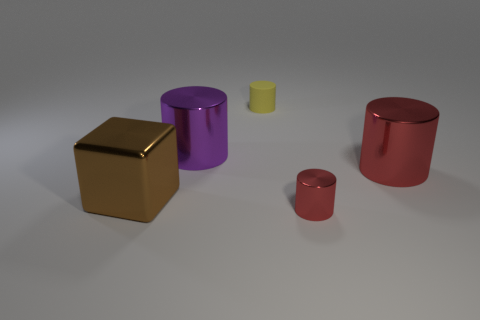Subtract all purple cylinders. Subtract all red blocks. How many cylinders are left? 3 Add 2 small metal cylinders. How many objects exist? 7 Subtract all blocks. How many objects are left? 4 Subtract all big yellow matte cubes. Subtract all big brown metal objects. How many objects are left? 4 Add 4 yellow matte cylinders. How many yellow matte cylinders are left? 5 Add 4 shiny cubes. How many shiny cubes exist? 5 Subtract 0 purple balls. How many objects are left? 5 